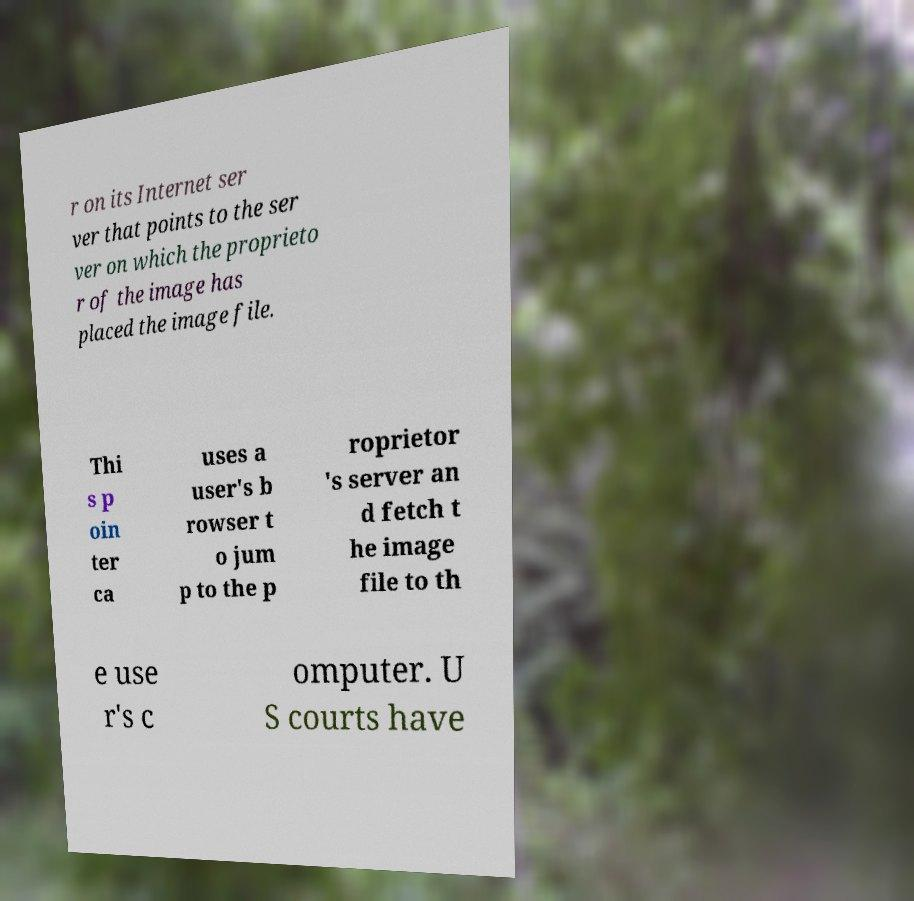What messages or text are displayed in this image? I need them in a readable, typed format. r on its Internet ser ver that points to the ser ver on which the proprieto r of the image has placed the image file. Thi s p oin ter ca uses a user's b rowser t o jum p to the p roprietor 's server an d fetch t he image file to th e use r's c omputer. U S courts have 